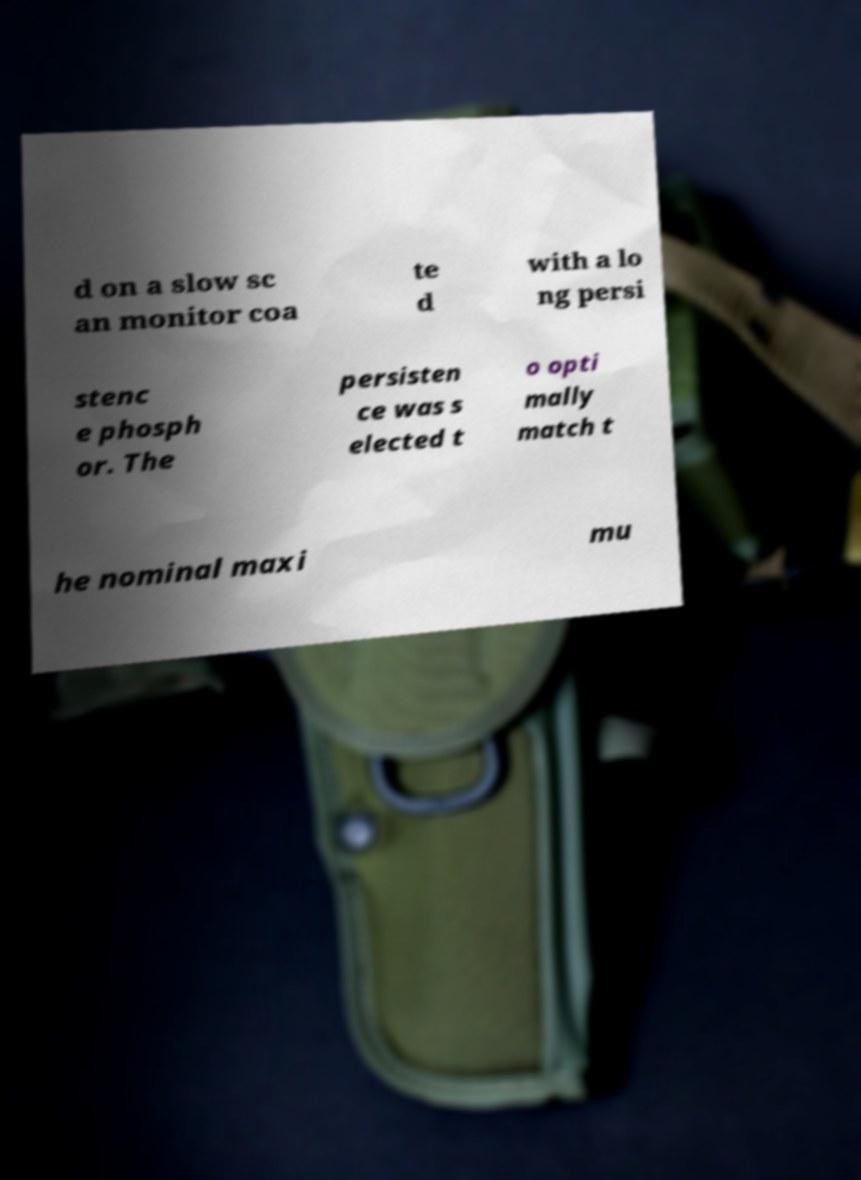There's text embedded in this image that I need extracted. Can you transcribe it verbatim? d on a slow sc an monitor coa te d with a lo ng persi stenc e phosph or. The persisten ce was s elected t o opti mally match t he nominal maxi mu 